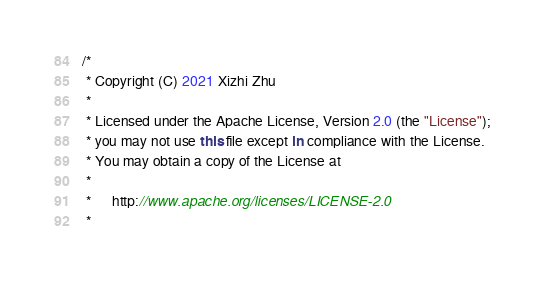Convert code to text. <code><loc_0><loc_0><loc_500><loc_500><_Kotlin_>/*
 * Copyright (C) 2021 Xizhi Zhu
 *
 * Licensed under the Apache License, Version 2.0 (the "License");
 * you may not use this file except in compliance with the License.
 * You may obtain a copy of the License at
 *
 *      http://www.apache.org/licenses/LICENSE-2.0
 *</code> 